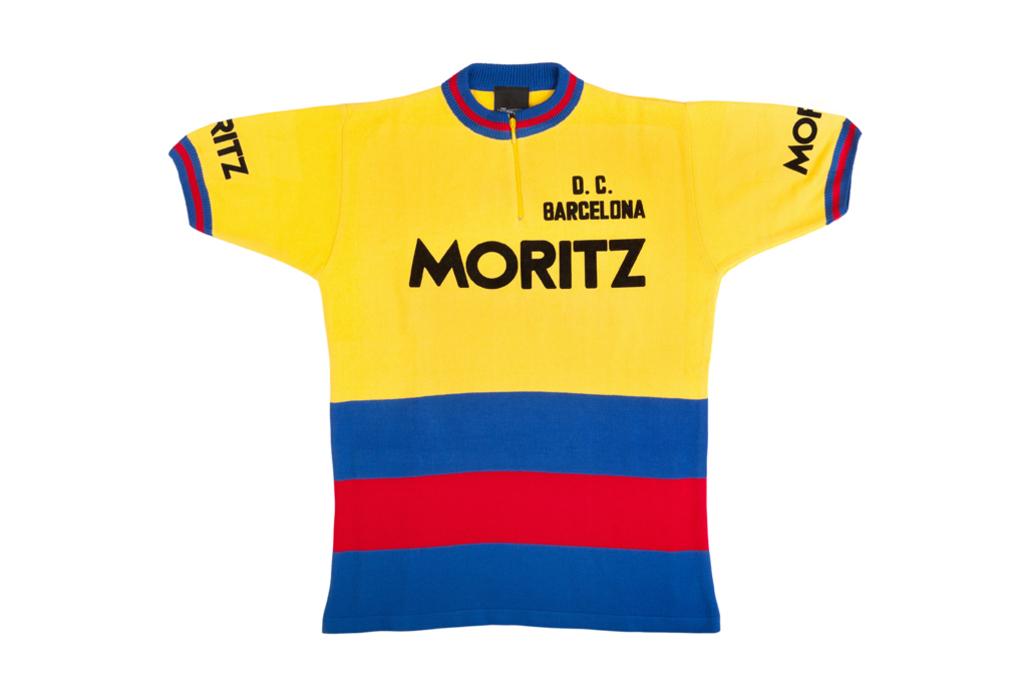What city in spain is referenced on this shirt?
Your answer should be very brief. Barcelona. What does the large black text say?
Make the answer very short. Moritz. 